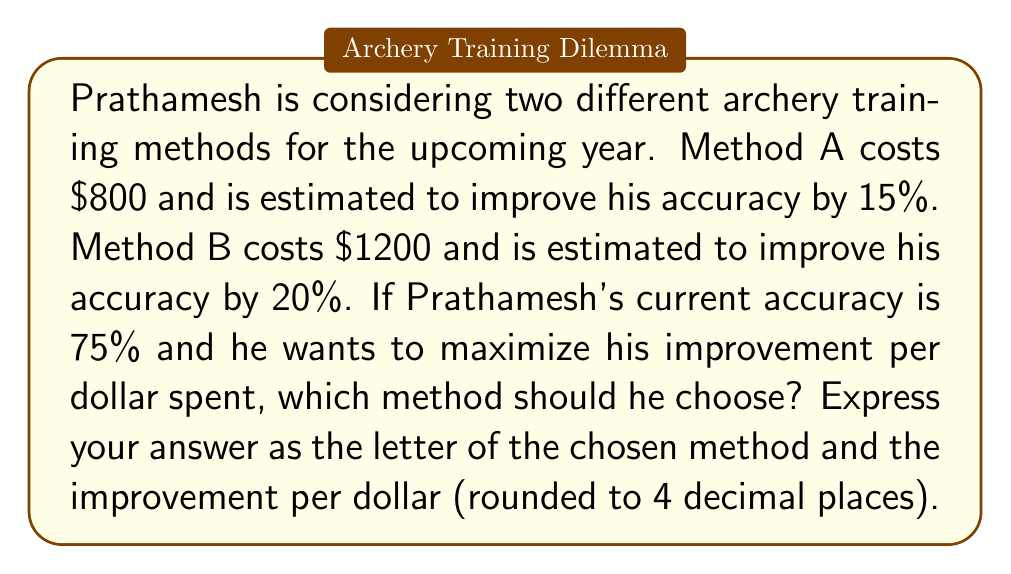Help me with this question. To solve this problem, we need to calculate the improvement per dollar for each method and compare them:

1. Method A:
   - Cost: $800
   - Improvement: 15% = 0.15
   - Current accuracy: 75% = 0.75
   - New accuracy: $0.75 + (0.75 \times 0.15) = 0.8625$ or 86.25%
   - Absolute improvement: $0.8625 - 0.75 = 0.1125$ or 11.25 percentage points
   - Improvement per dollar: $\frac{0.1125}{800} = 0.00014063$

2. Method B:
   - Cost: $1200
   - Improvement: 20% = 0.20
   - Current accuracy: 75% = 0.75
   - New accuracy: $0.75 + (0.75 \times 0.20) = 0.90$ or 90%
   - Absolute improvement: $0.90 - 0.75 = 0.15$ or 15 percentage points
   - Improvement per dollar: $\frac{0.15}{1200} = 0.000125$

Comparing the improvement per dollar:
Method A: 0.00014063
Method B: 0.000125

Method A provides a higher improvement per dollar, so Prathamesh should choose Method A.
Answer: A, 0.0001 